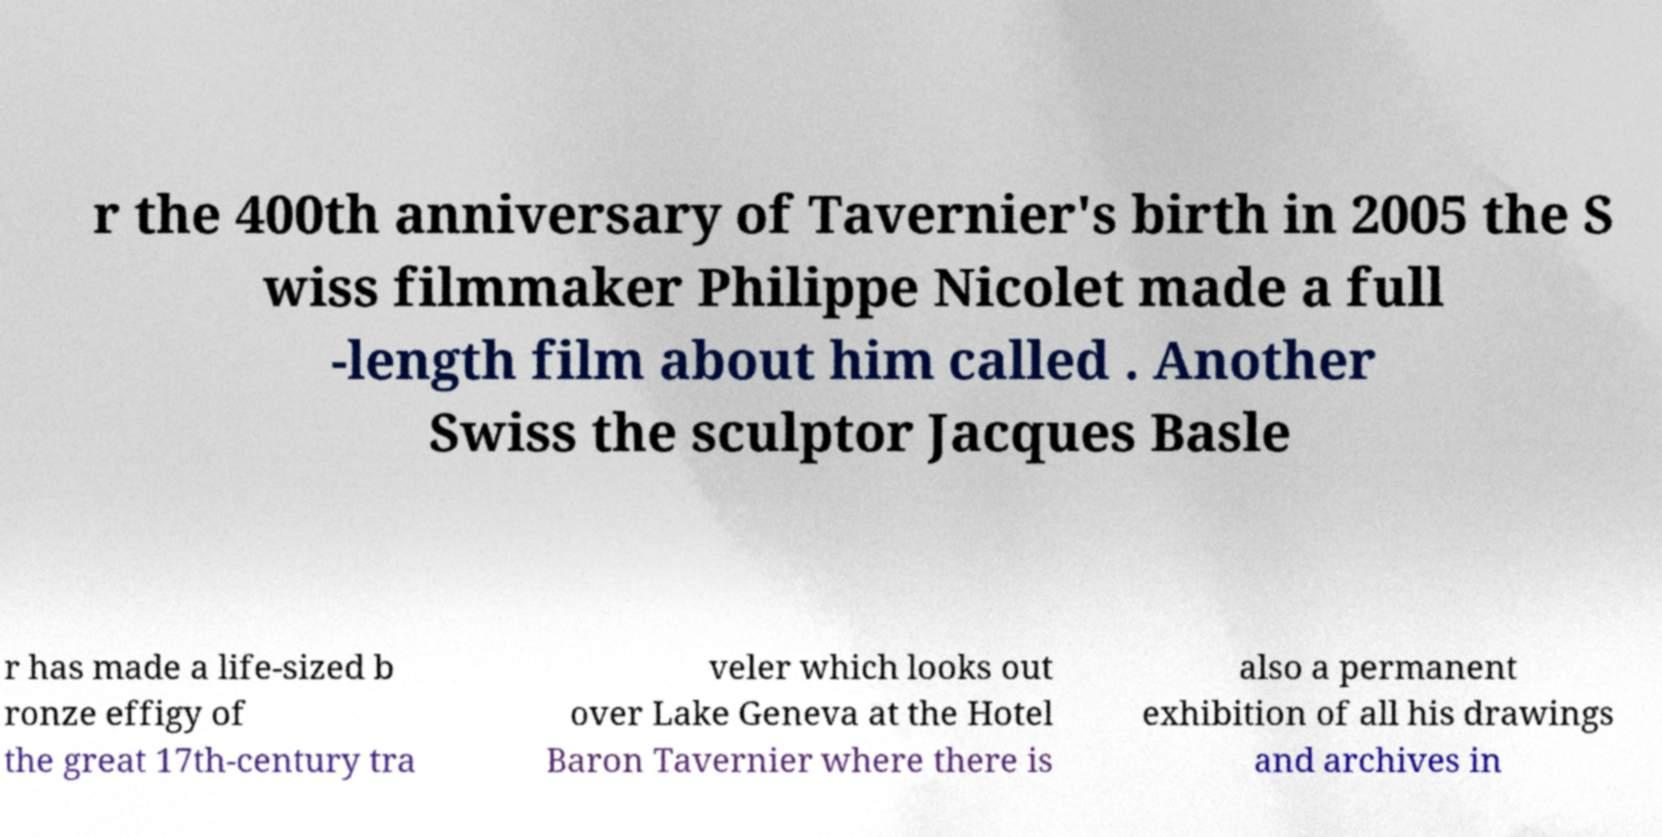Please read and relay the text visible in this image. What does it say? r the 400th anniversary of Tavernier's birth in 2005 the S wiss filmmaker Philippe Nicolet made a full -length film about him called . Another Swiss the sculptor Jacques Basle r has made a life-sized b ronze effigy of the great 17th-century tra veler which looks out over Lake Geneva at the Hotel Baron Tavernier where there is also a permanent exhibition of all his drawings and archives in 